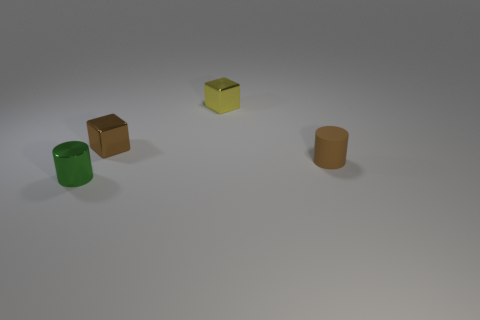Subtract all green cylinders. How many cylinders are left? 1 Subtract 2 cylinders. How many cylinders are left? 0 Add 3 yellow cubes. How many objects exist? 7 Subtract all red cylinders. Subtract all brown blocks. How many cylinders are left? 2 Subtract all gray cylinders. How many yellow blocks are left? 1 Subtract all cylinders. Subtract all small brown cylinders. How many objects are left? 1 Add 1 cylinders. How many cylinders are left? 3 Add 4 tiny brown rubber cylinders. How many tiny brown rubber cylinders exist? 5 Subtract 0 blue cylinders. How many objects are left? 4 